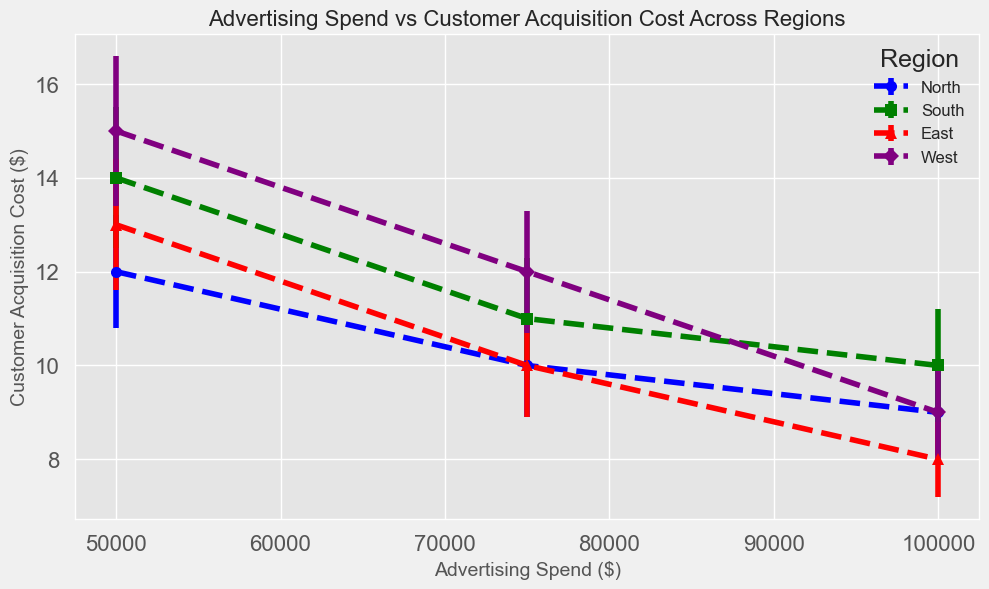Which region has the highest customer acquisition cost at the lowest advertising spend? Refer to the y-values at the lowest x-value (Advertising Spend = $50,000). The West region has the highest customer acquisition cost (15 dollars).
Answer: The West What is the range of customer acquisition costs in the North region across all advertising spends? Check the y-values for North data points. The costs range from 9 to 12 dollars.
Answer: 3 dollars Which region has the smallest error margin at the highest advertising spend? Look at the error margins at the highest x-value ($100,000). The East region has the smallest error margin (0.8).
Answer: The East In which region does the customer acquisition cost decrease as advertising spend increases? Compare the slopes of the graphs for each region. The North and East regions show a decreasing trend in customer acquisition costs with increasing advertising spend.
Answer: North, East How does the average customer acquisition cost in the South region compare to that of the West region? Calculate the average customer acquisition cost for South and West. South: (14+11+10)/3 = 11.67; West: (15+12+9)/3 = 12.
Answer: South: 11.67, West: 12 What is the difference in customer acquisition cost between the East and West at an advertising spend of $75,000? Check the y-values for East and West at $75,000. Difference is 12 - 10 = 2 dollars.
Answer: 2 dollars Which region has the most consistent customer acquisition costs, as indicated by the smallest error margins? Evaluate the error margins across all data points. The East region has the smallest error margins overall.
Answer: The East Between the North and South regions, which has a lower average customer acquisition cost at $50,000 advertising spend? Compare the y-values for North and South at $50,000. North: 12; South: 14. North has the lower cost.
Answer: North Which color corresponds to the East region in the plot? Identify the legend to find the color representation of the East region. The color for the East is red.
Answer: Red 